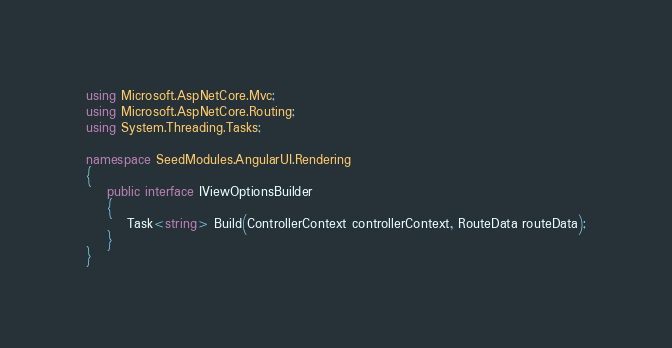Convert code to text. <code><loc_0><loc_0><loc_500><loc_500><_C#_>using Microsoft.AspNetCore.Mvc;
using Microsoft.AspNetCore.Routing;
using System.Threading.Tasks;

namespace SeedModules.AngularUI.Rendering
{
    public interface IViewOptionsBuilder
    {
        Task<string> Build(ControllerContext controllerContext, RouteData routeData);
    }
}</code> 